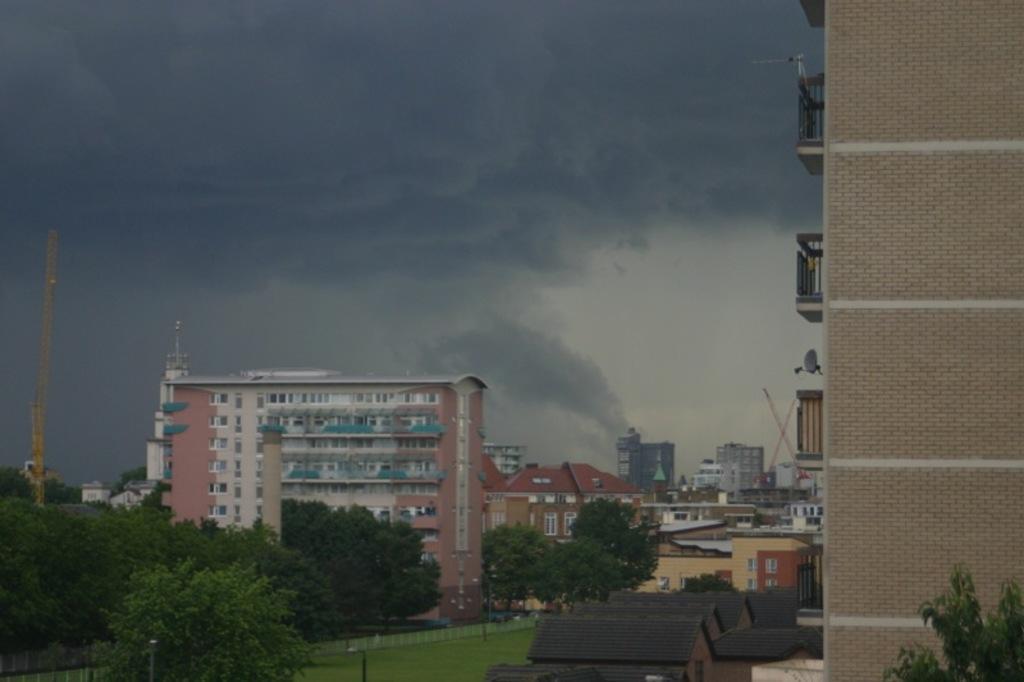Please provide a concise description of this image. In this image I can see the houses. On the left side I can see the trees. In the background, I can see the buildings and clouds in the sky. 